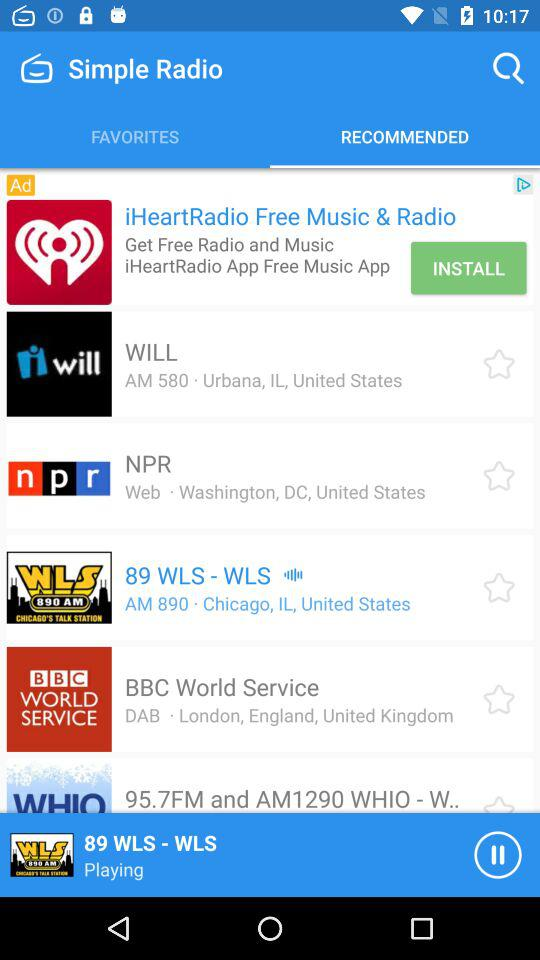What is the location of "89 WLS"? The location of "89 WLS" is Chicago, IL, United States. 